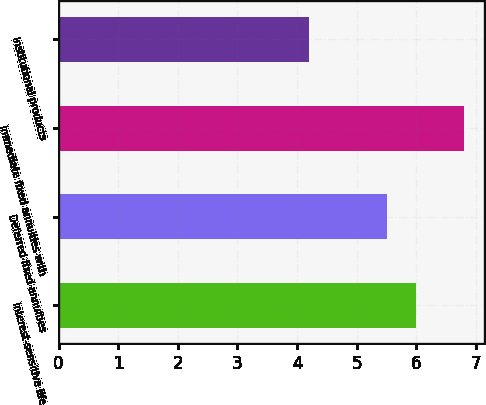<chart> <loc_0><loc_0><loc_500><loc_500><bar_chart><fcel>Interest-sensitive life<fcel>Deferred fixed annuities<fcel>Immediate fixed annuities with<fcel>Institutional products<nl><fcel>6<fcel>5.5<fcel>6.8<fcel>4.2<nl></chart> 